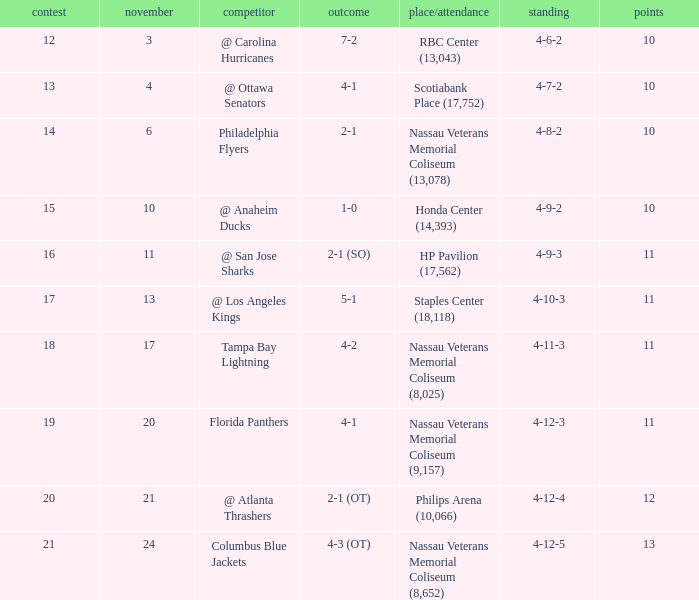What is every game on November 21? 20.0. 